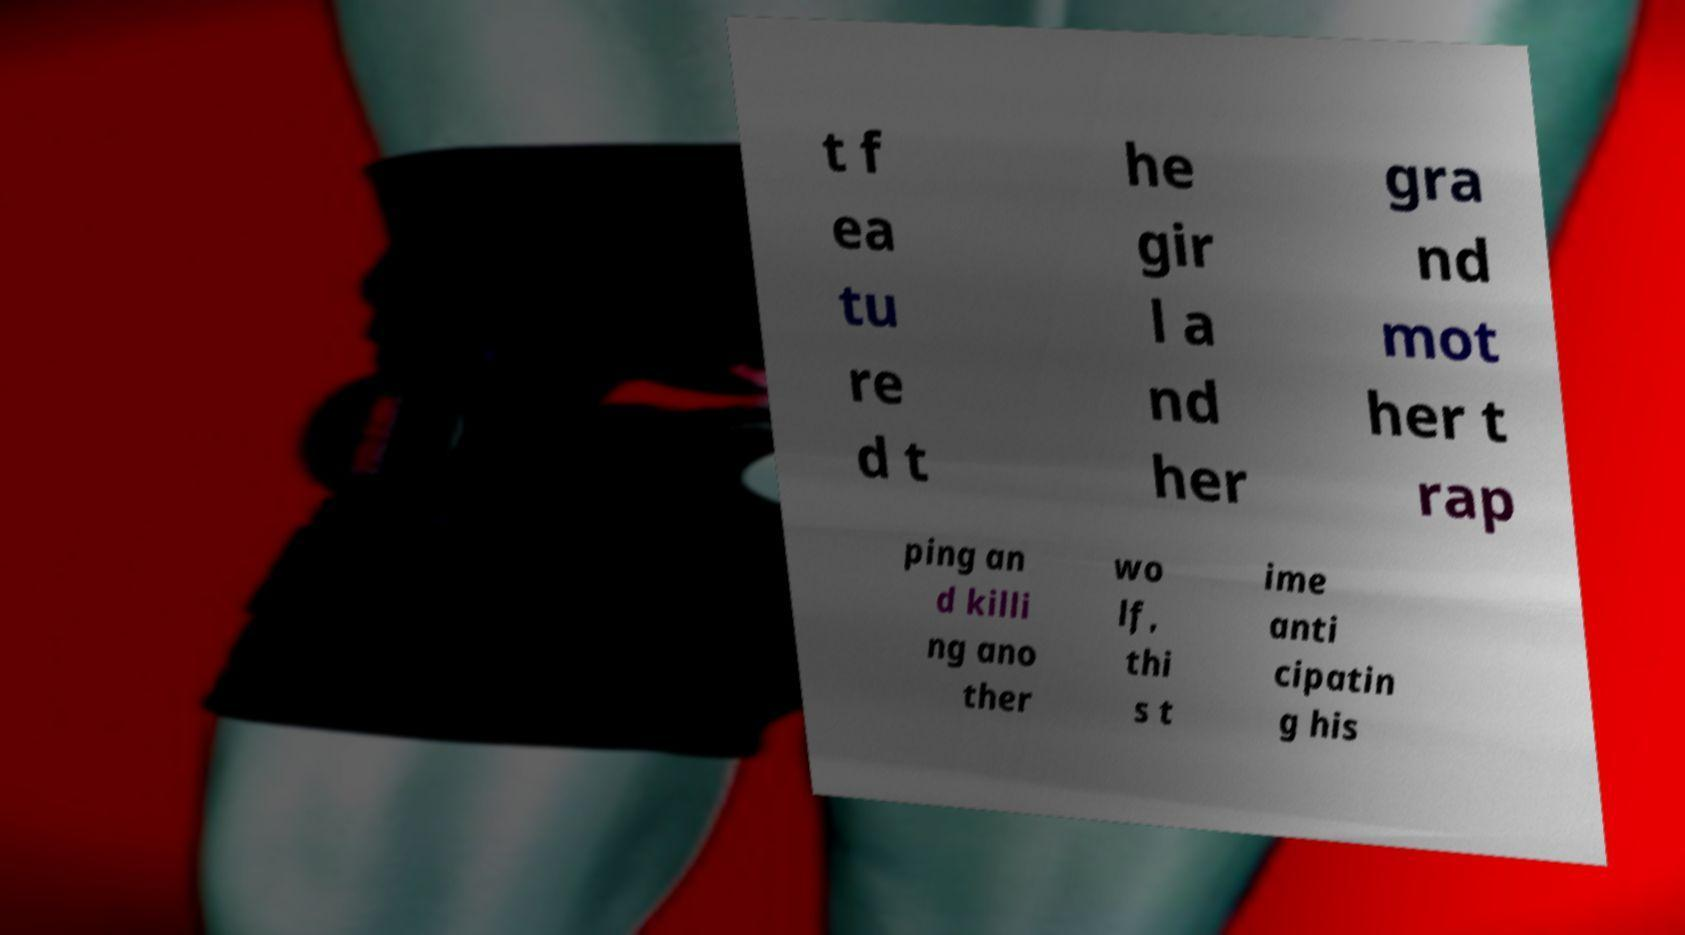Could you extract and type out the text from this image? t f ea tu re d t he gir l a nd her gra nd mot her t rap ping an d killi ng ano ther wo lf, thi s t ime anti cipatin g his 